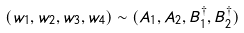<formula> <loc_0><loc_0><loc_500><loc_500>( w _ { 1 } , w _ { 2 } , w _ { 3 } , w _ { 4 } ) \sim ( A _ { 1 } , A _ { 2 } , B _ { 1 } ^ { \dagger } , B _ { 2 } ^ { \dagger } )</formula> 